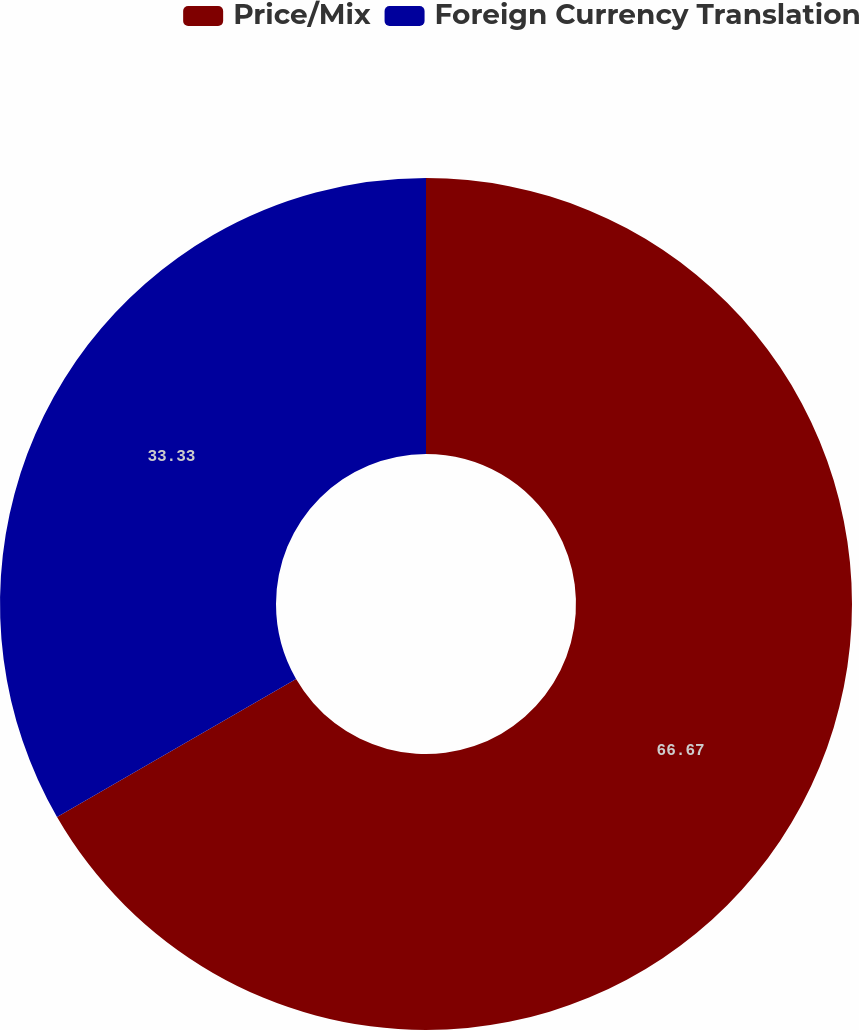Convert chart to OTSL. <chart><loc_0><loc_0><loc_500><loc_500><pie_chart><fcel>Price/Mix<fcel>Foreign Currency Translation<nl><fcel>66.67%<fcel>33.33%<nl></chart> 